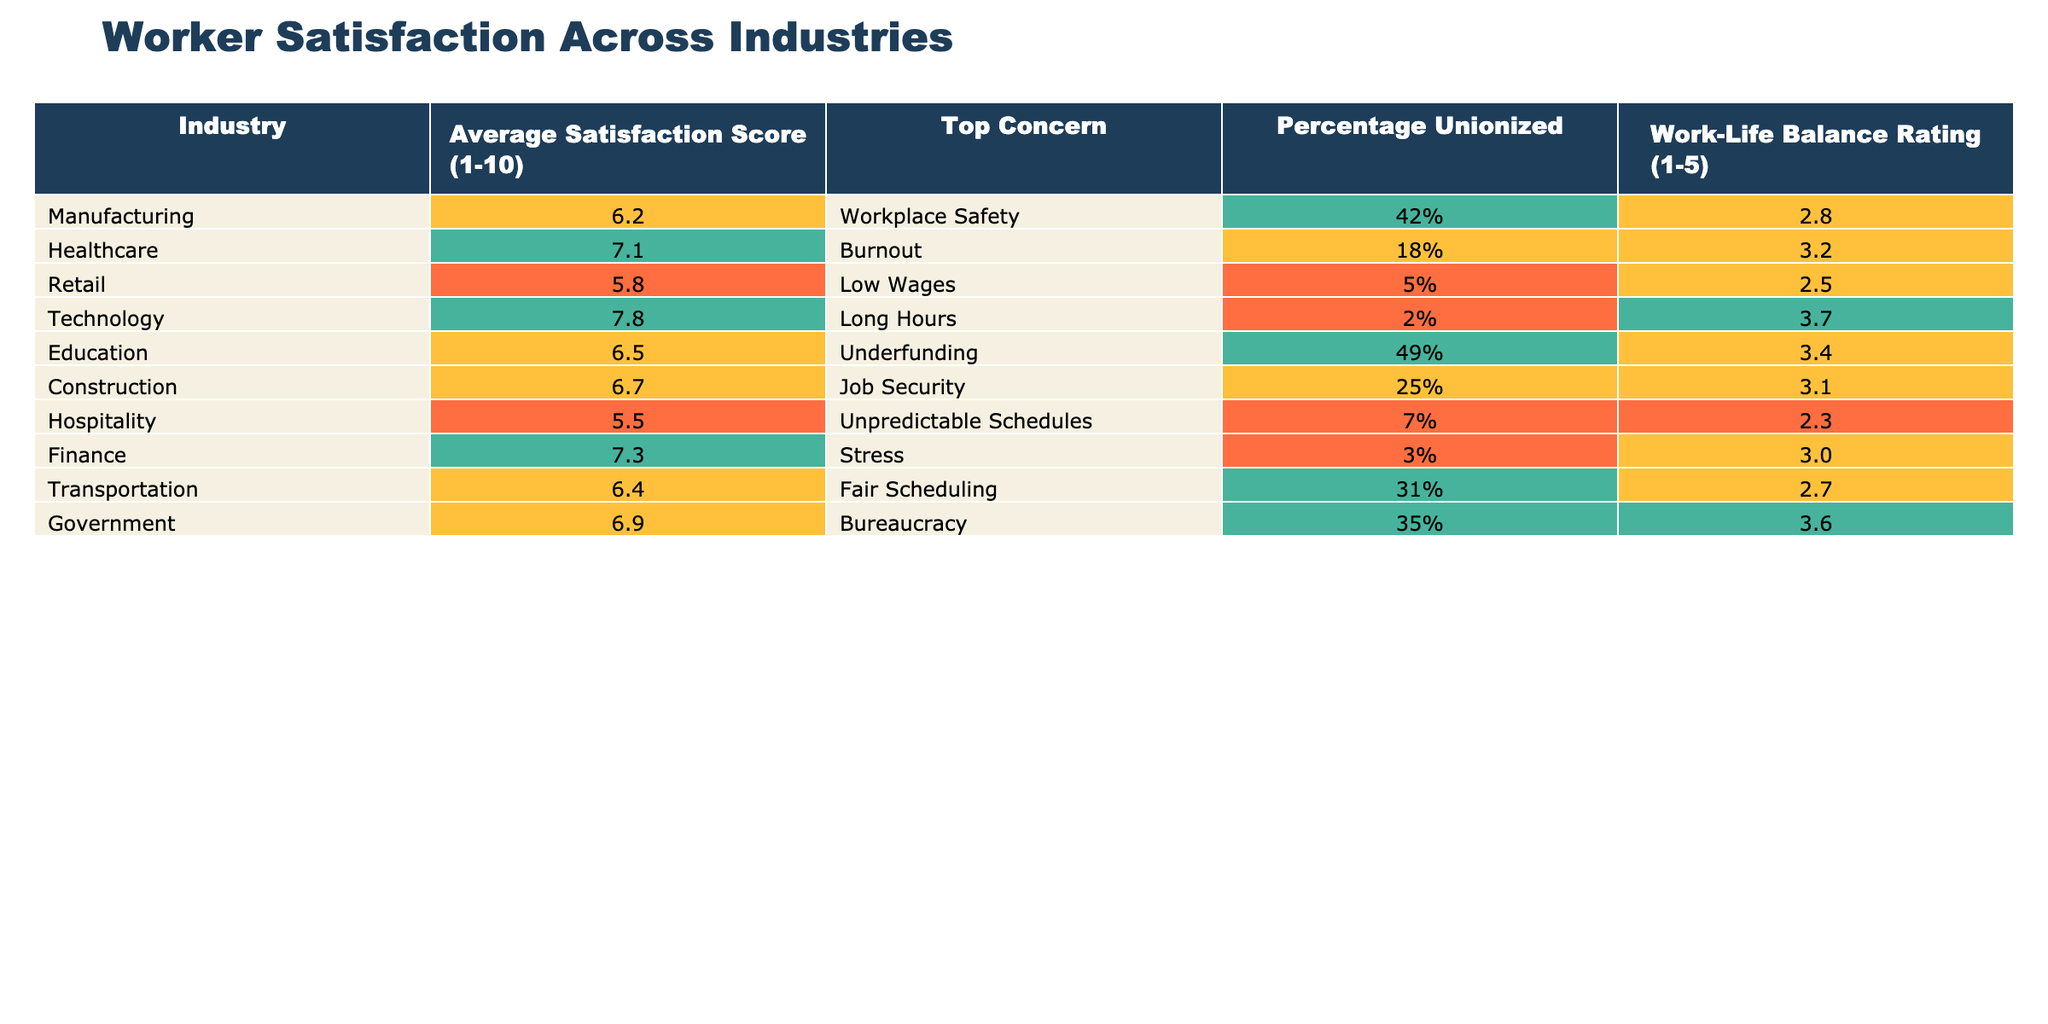What is the average satisfaction score for the Retail industry? The table lists the average satisfaction score for the Retail industry as 5.8.
Answer: 5.8 Which industry has the highest average satisfaction score? The table shows that the Technology industry has the highest average satisfaction score at 7.8.
Answer: 7.8 Is the percentage of workers unionized in the Healthcare industry greater than that in the Retail industry? The Healthcare industry has 18% unionized workers, while the Retail industry has only 5%, which makes it greater.
Answer: Yes What is the average work-life balance rating across all industries? To find the average, sum the work-life balance ratings (2.8 + 3.2 + 2.5 + 3.7 + 3.4 + 3.1 + 2.3 + 3.0 + 2.7 + 3.6) = 31.8, then divide by 10 industries to get 31.8 / 10 = 3.18.
Answer: 3.18 Which industry has the lowest score for work-life balance? The table indicates that the Hospitality industry has the lowest work-life balance rating of 2.3.
Answer: 2.3 Are more workers unionized in the Manufacturing sector than in the Healthcare sector? The Manufacturing sector has 42% unionized workers, while the Healthcare sector has 18%, indicating that more are in Manufacturing.
Answer: Yes What is the difference in average satisfaction scores between the Technology and Construction industries? The Technology industry has an average satisfaction score of 7.8, and the Construction industry has 6.7. The difference is calculated as 7.8 - 6.7 = 1.1.
Answer: 1.1 Which industry expresses “low wages” as a top concern? According to the table, the Retail industry lists "Low Wages" as its top concern.
Answer: Retail What is the average percentage of unionized workers across all industries? To find the average percentage of unionized workers, convert to decimals, sum them (0.42 + 0.18 + 0.05 + 0.02 + 0.49 + 0.25 + 0.07 + 0.03 + 0.31 + 0.35) = 1.77 and then divide by 10, giving 1.77 / 10 = 0.177, which equates to 17.7%.
Answer: 17.7% Which industry prioritizes job security as the top concern? The Construction industry lists "Job Security" as its top concern according to the table.
Answer: Construction 